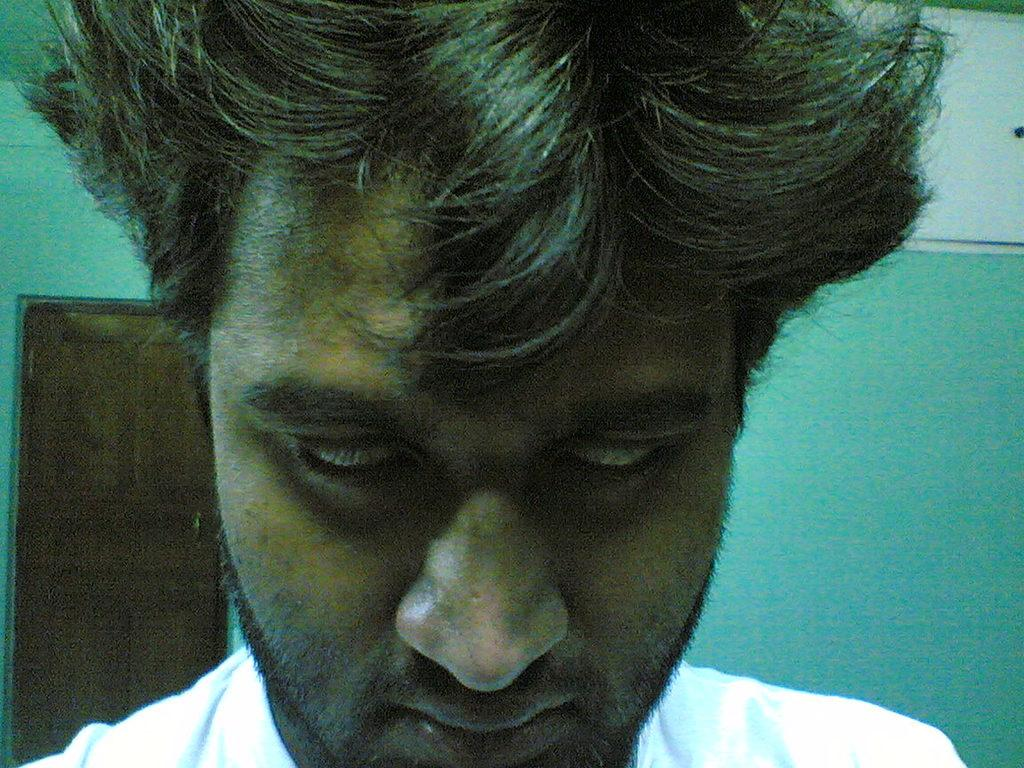Who is present in the image? There is a man in the image. What can be seen in the background of the image? There is a door and a wall in the background of the image. Reasoning: Let' Let's think step by step in order to produce the conversation. We start by identifying the main subject in the image, which is the man. Then, we expand the conversation to include other elements that are also visible in the background, such as the door and the wall. Each question is designed to elicit a specific detail about the image that is known from the provided facts. Absurd Question/Answer: How many bridges can be seen in the image? There are no bridges present in the image. What type of ear is visible on the man in the image? The image does not show the man's ears, so it cannot be determined what type of ear is visible. What type of station is visible in the image? There is no station present in the image. 